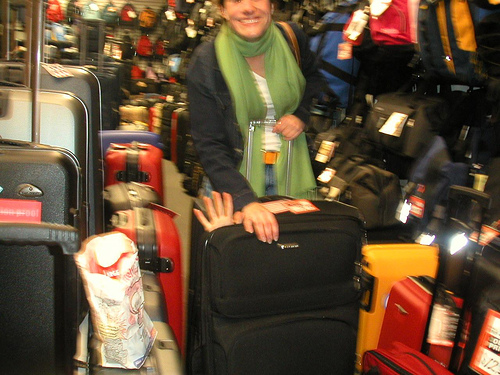Can you describe the person in the image? Certainly! There is a person with a smile, standing next to a piece of black luggage. They are wearing a green scarf, a dark jacket, and holding a clear plastic cup. It appears they may be in a luggage store or in an area with many travel items. What does their presence suggest about the location? The presence of the person, who seems to be in good spirits and casually dressed, along with the numerous pieces of luggage around them, suggests they might be in a travel-related setting, such as a luggage store or possibly an airport shopping area. 